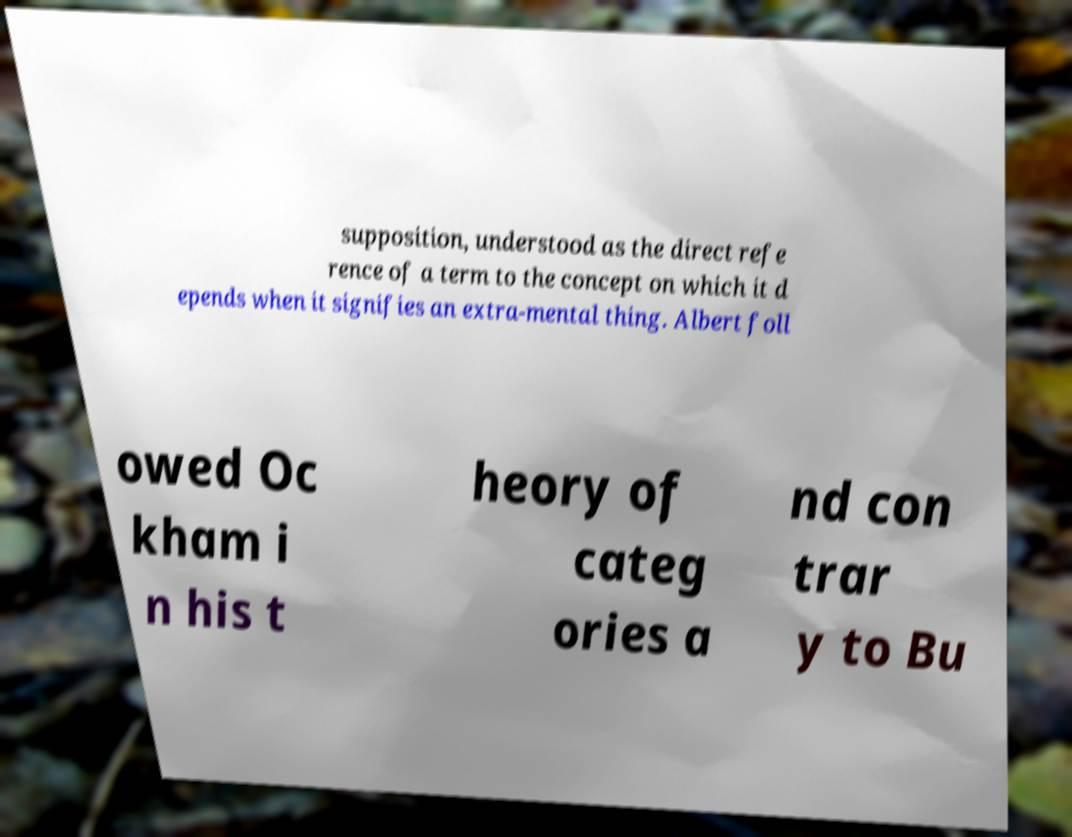For documentation purposes, I need the text within this image transcribed. Could you provide that? supposition, understood as the direct refe rence of a term to the concept on which it d epends when it signifies an extra-mental thing. Albert foll owed Oc kham i n his t heory of categ ories a nd con trar y to Bu 